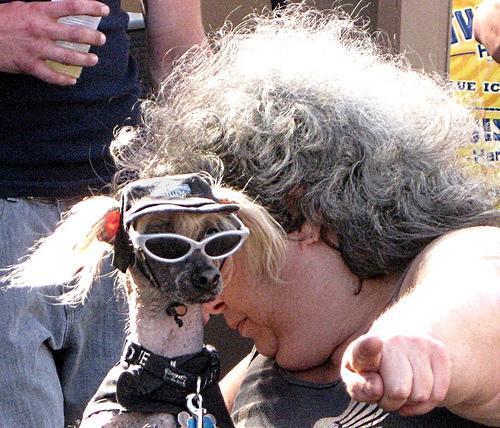How many dogs are there?
Give a very brief answer. 1. 